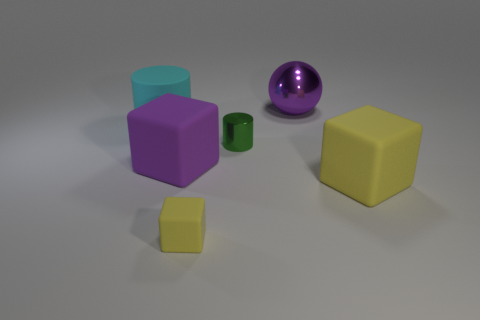There is a big block that is the same color as the sphere; what is its material?
Provide a succinct answer. Rubber. The matte object that is the same color as the small cube is what size?
Offer a terse response. Large. The large matte thing that is in front of the purple cube has what shape?
Offer a terse response. Cube. What number of purple metallic balls are in front of the rubber object right of the shiny thing in front of the large cylinder?
Keep it short and to the point. 0. Does the metal cylinder have the same size as the yellow cube that is on the right side of the small yellow thing?
Provide a short and direct response. No. What is the size of the yellow block to the left of the purple object on the right side of the tiny yellow rubber thing?
Ensure brevity in your answer.  Small. What number of tiny cubes are made of the same material as the big yellow cube?
Provide a short and direct response. 1. Are any big purple balls visible?
Ensure brevity in your answer.  Yes. What size is the rubber thing that is right of the big metallic thing?
Your response must be concise. Large. How many shiny objects have the same color as the large cylinder?
Your answer should be very brief. 0. 